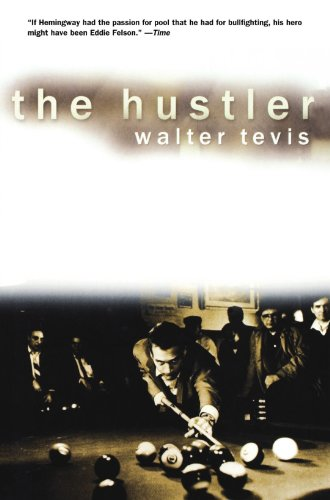Is this book related to Religion & Spirituality? No, 'The Hustler' does not delve into themes of Religion & Spirituality; it is principally focused on the sport of billiards and the life challenges facing its protagonist. 